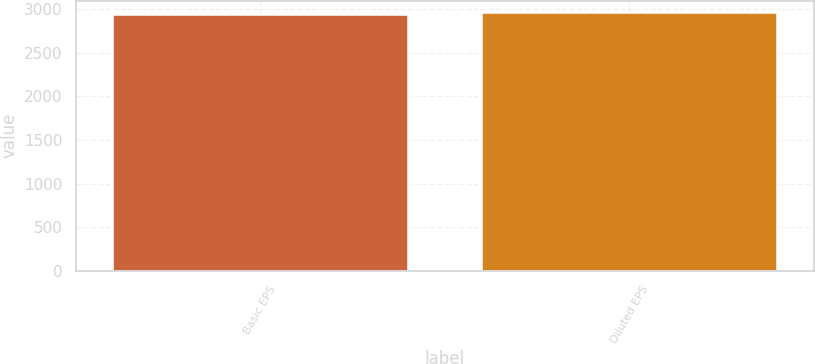Convert chart to OTSL. <chart><loc_0><loc_0><loc_500><loc_500><bar_chart><fcel>Basic EPS<fcel>Diluted EPS<nl><fcel>2939<fcel>2952<nl></chart> 